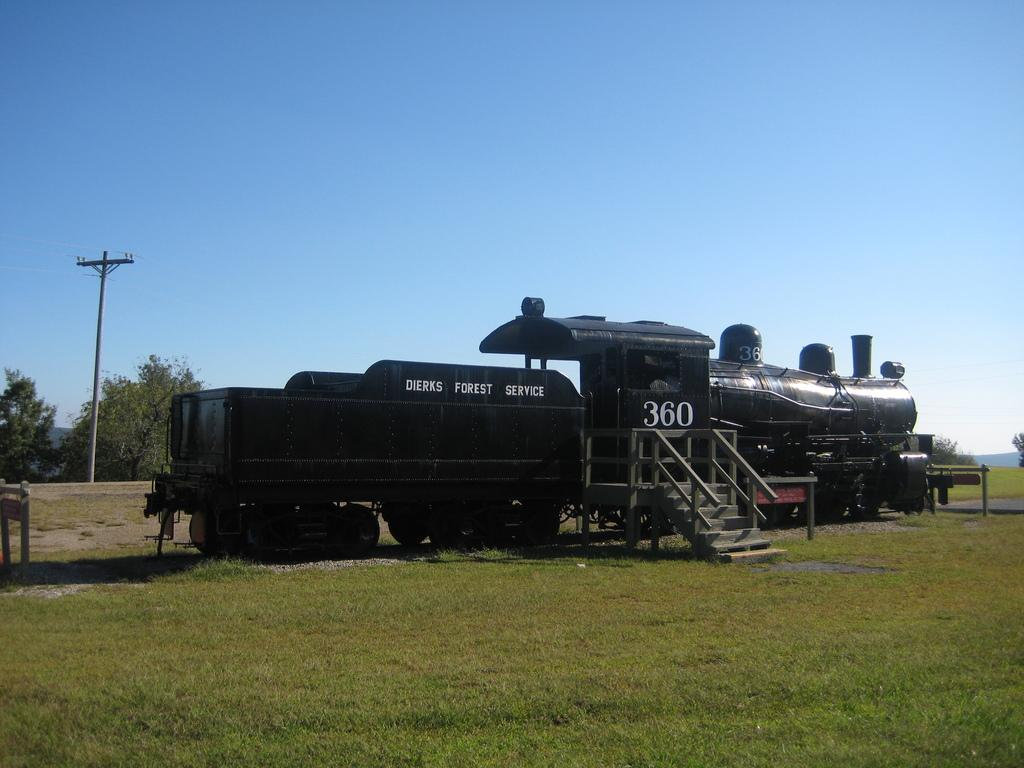What is the main subject of the image? The main subject of the image is a train engine. Are there any additional structures or features in the image? Yes, there are stairs on the surface of the grass and a utility pole in the background of the image. What can be seen in the background of the image? In the background of the image, there are trees and the sky is visible. What type of brass instrument is being played by the trees in the background? There is no brass instrument being played by the trees in the background, as trees are not capable of playing musical instruments. 